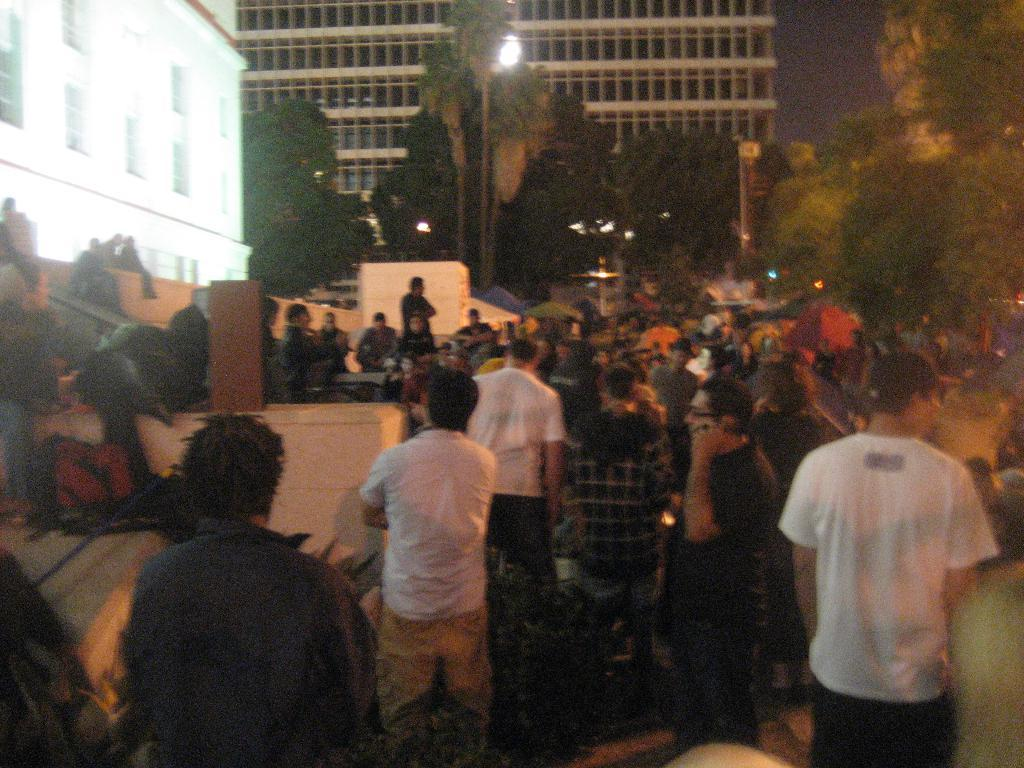How many people are visible in the image? There are many people in the image. What can be seen in the background of the image? There are trees, buildings, and lights in the background of the image. Where is the stage located in the image? The stage is on the left side of the image. What verse is being recited by the people in the image? There is no indication in the image that people are reciting a verse, so it cannot be determined from the picture. 